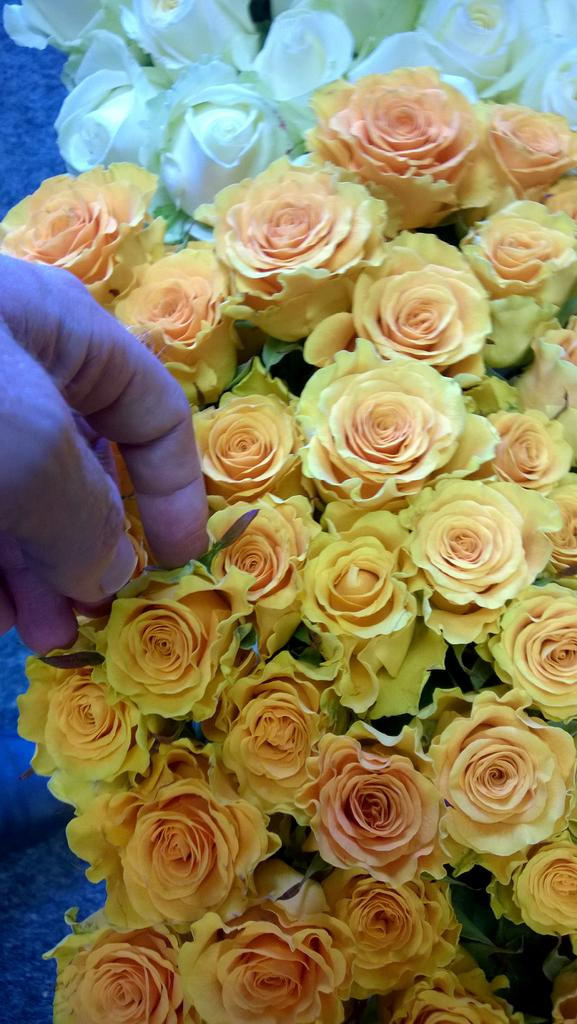What body parts are visible in the image? There are persons' hands visible in the image. What type of floral elements are present in the image? There are flowers in the image. What type of scarf is being worn by the expert in the image? There is no scarf or expert present in the image. How does the image convey respect among the individuals? The image does not convey respect among individuals, as it only shows hands and flowers. 